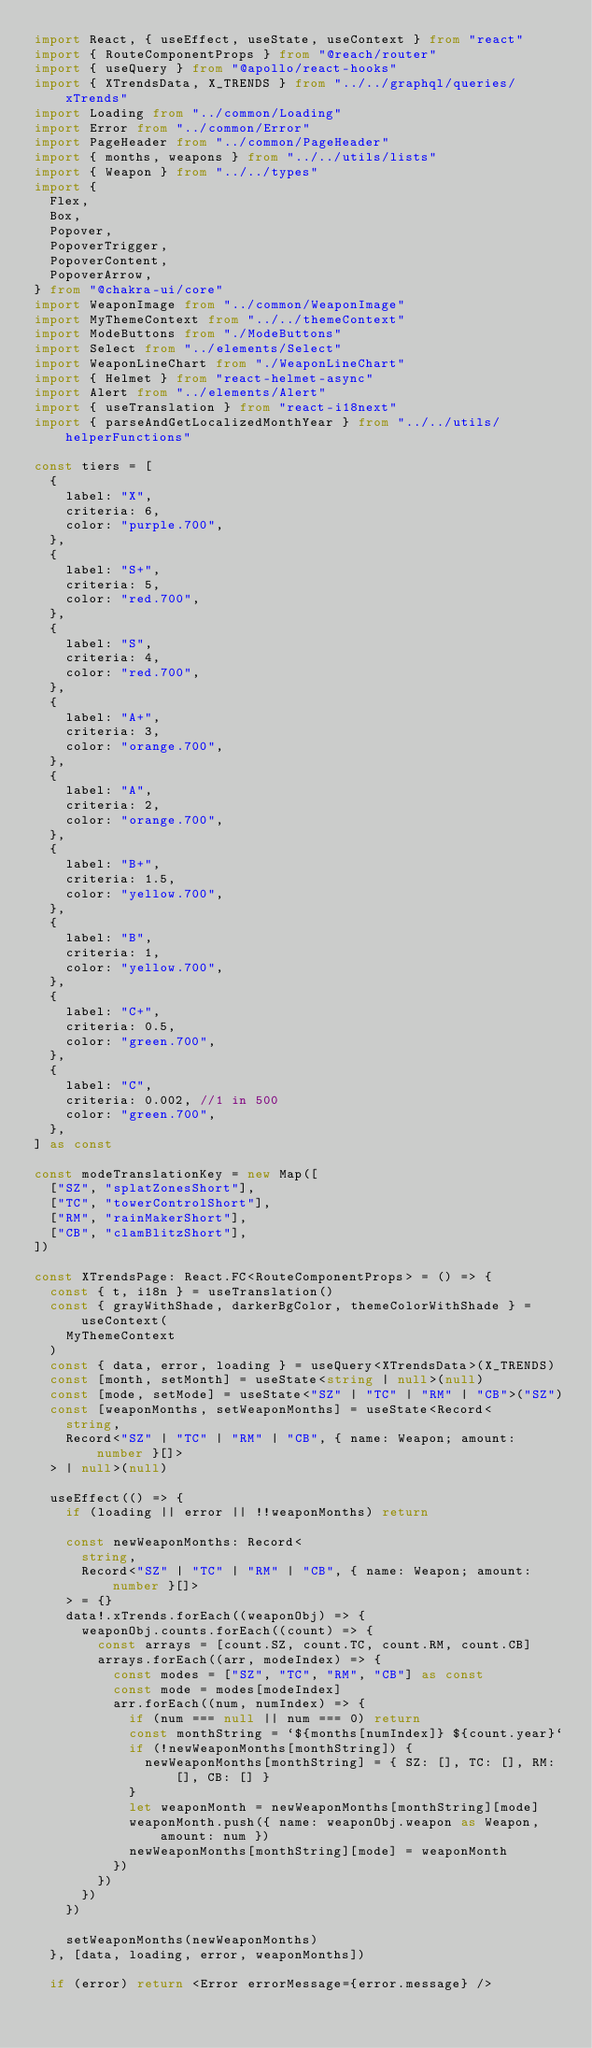<code> <loc_0><loc_0><loc_500><loc_500><_TypeScript_>import React, { useEffect, useState, useContext } from "react"
import { RouteComponentProps } from "@reach/router"
import { useQuery } from "@apollo/react-hooks"
import { XTrendsData, X_TRENDS } from "../../graphql/queries/xTrends"
import Loading from "../common/Loading"
import Error from "../common/Error"
import PageHeader from "../common/PageHeader"
import { months, weapons } from "../../utils/lists"
import { Weapon } from "../../types"
import {
  Flex,
  Box,
  Popover,
  PopoverTrigger,
  PopoverContent,
  PopoverArrow,
} from "@chakra-ui/core"
import WeaponImage from "../common/WeaponImage"
import MyThemeContext from "../../themeContext"
import ModeButtons from "./ModeButtons"
import Select from "../elements/Select"
import WeaponLineChart from "./WeaponLineChart"
import { Helmet } from "react-helmet-async"
import Alert from "../elements/Alert"
import { useTranslation } from "react-i18next"
import { parseAndGetLocalizedMonthYear } from "../../utils/helperFunctions"

const tiers = [
  {
    label: "X",
    criteria: 6,
    color: "purple.700",
  },
  {
    label: "S+",
    criteria: 5,
    color: "red.700",
  },
  {
    label: "S",
    criteria: 4,
    color: "red.700",
  },
  {
    label: "A+",
    criteria: 3,
    color: "orange.700",
  },
  {
    label: "A",
    criteria: 2,
    color: "orange.700",
  },
  {
    label: "B+",
    criteria: 1.5,
    color: "yellow.700",
  },
  {
    label: "B",
    criteria: 1,
    color: "yellow.700",
  },
  {
    label: "C+",
    criteria: 0.5,
    color: "green.700",
  },
  {
    label: "C",
    criteria: 0.002, //1 in 500
    color: "green.700",
  },
] as const

const modeTranslationKey = new Map([
  ["SZ", "splatZonesShort"],
  ["TC", "towerControlShort"],
  ["RM", "rainMakerShort"],
  ["CB", "clamBlitzShort"],
])

const XTrendsPage: React.FC<RouteComponentProps> = () => {
  const { t, i18n } = useTranslation()
  const { grayWithShade, darkerBgColor, themeColorWithShade } = useContext(
    MyThemeContext
  )
  const { data, error, loading } = useQuery<XTrendsData>(X_TRENDS)
  const [month, setMonth] = useState<string | null>(null)
  const [mode, setMode] = useState<"SZ" | "TC" | "RM" | "CB">("SZ")
  const [weaponMonths, setWeaponMonths] = useState<Record<
    string,
    Record<"SZ" | "TC" | "RM" | "CB", { name: Weapon; amount: number }[]>
  > | null>(null)

  useEffect(() => {
    if (loading || error || !!weaponMonths) return

    const newWeaponMonths: Record<
      string,
      Record<"SZ" | "TC" | "RM" | "CB", { name: Weapon; amount: number }[]>
    > = {}
    data!.xTrends.forEach((weaponObj) => {
      weaponObj.counts.forEach((count) => {
        const arrays = [count.SZ, count.TC, count.RM, count.CB]
        arrays.forEach((arr, modeIndex) => {
          const modes = ["SZ", "TC", "RM", "CB"] as const
          const mode = modes[modeIndex]
          arr.forEach((num, numIndex) => {
            if (num === null || num === 0) return
            const monthString = `${months[numIndex]} ${count.year}`
            if (!newWeaponMonths[monthString]) {
              newWeaponMonths[monthString] = { SZ: [], TC: [], RM: [], CB: [] }
            }
            let weaponMonth = newWeaponMonths[monthString][mode]
            weaponMonth.push({ name: weaponObj.weapon as Weapon, amount: num })
            newWeaponMonths[monthString][mode] = weaponMonth
          })
        })
      })
    })

    setWeaponMonths(newWeaponMonths)
  }, [data, loading, error, weaponMonths])

  if (error) return <Error errorMessage={error.message} /></code> 